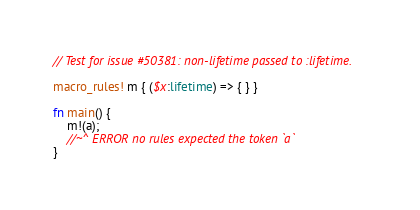Convert code to text. <code><loc_0><loc_0><loc_500><loc_500><_Rust_>// Test for issue #50381: non-lifetime passed to :lifetime.

macro_rules! m { ($x:lifetime) => { } }

fn main() {
    m!(a);
    //~^ ERROR no rules expected the token `a`
}
</code> 